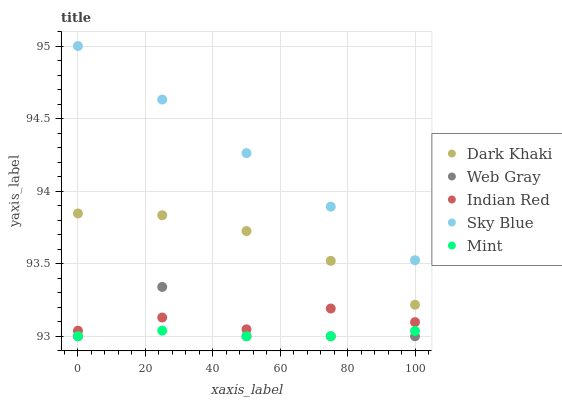Does Mint have the minimum area under the curve?
Answer yes or no. Yes. Does Sky Blue have the maximum area under the curve?
Answer yes or no. Yes. Does Web Gray have the minimum area under the curve?
Answer yes or no. No. Does Web Gray have the maximum area under the curve?
Answer yes or no. No. Is Sky Blue the smoothest?
Answer yes or no. Yes. Is Web Gray the roughest?
Answer yes or no. Yes. Is Web Gray the smoothest?
Answer yes or no. No. Is Sky Blue the roughest?
Answer yes or no. No. Does Web Gray have the lowest value?
Answer yes or no. Yes. Does Sky Blue have the lowest value?
Answer yes or no. No. Does Sky Blue have the highest value?
Answer yes or no. Yes. Does Web Gray have the highest value?
Answer yes or no. No. Is Indian Red less than Dark Khaki?
Answer yes or no. Yes. Is Indian Red greater than Mint?
Answer yes or no. Yes. Does Web Gray intersect Indian Red?
Answer yes or no. Yes. Is Web Gray less than Indian Red?
Answer yes or no. No. Is Web Gray greater than Indian Red?
Answer yes or no. No. Does Indian Red intersect Dark Khaki?
Answer yes or no. No. 